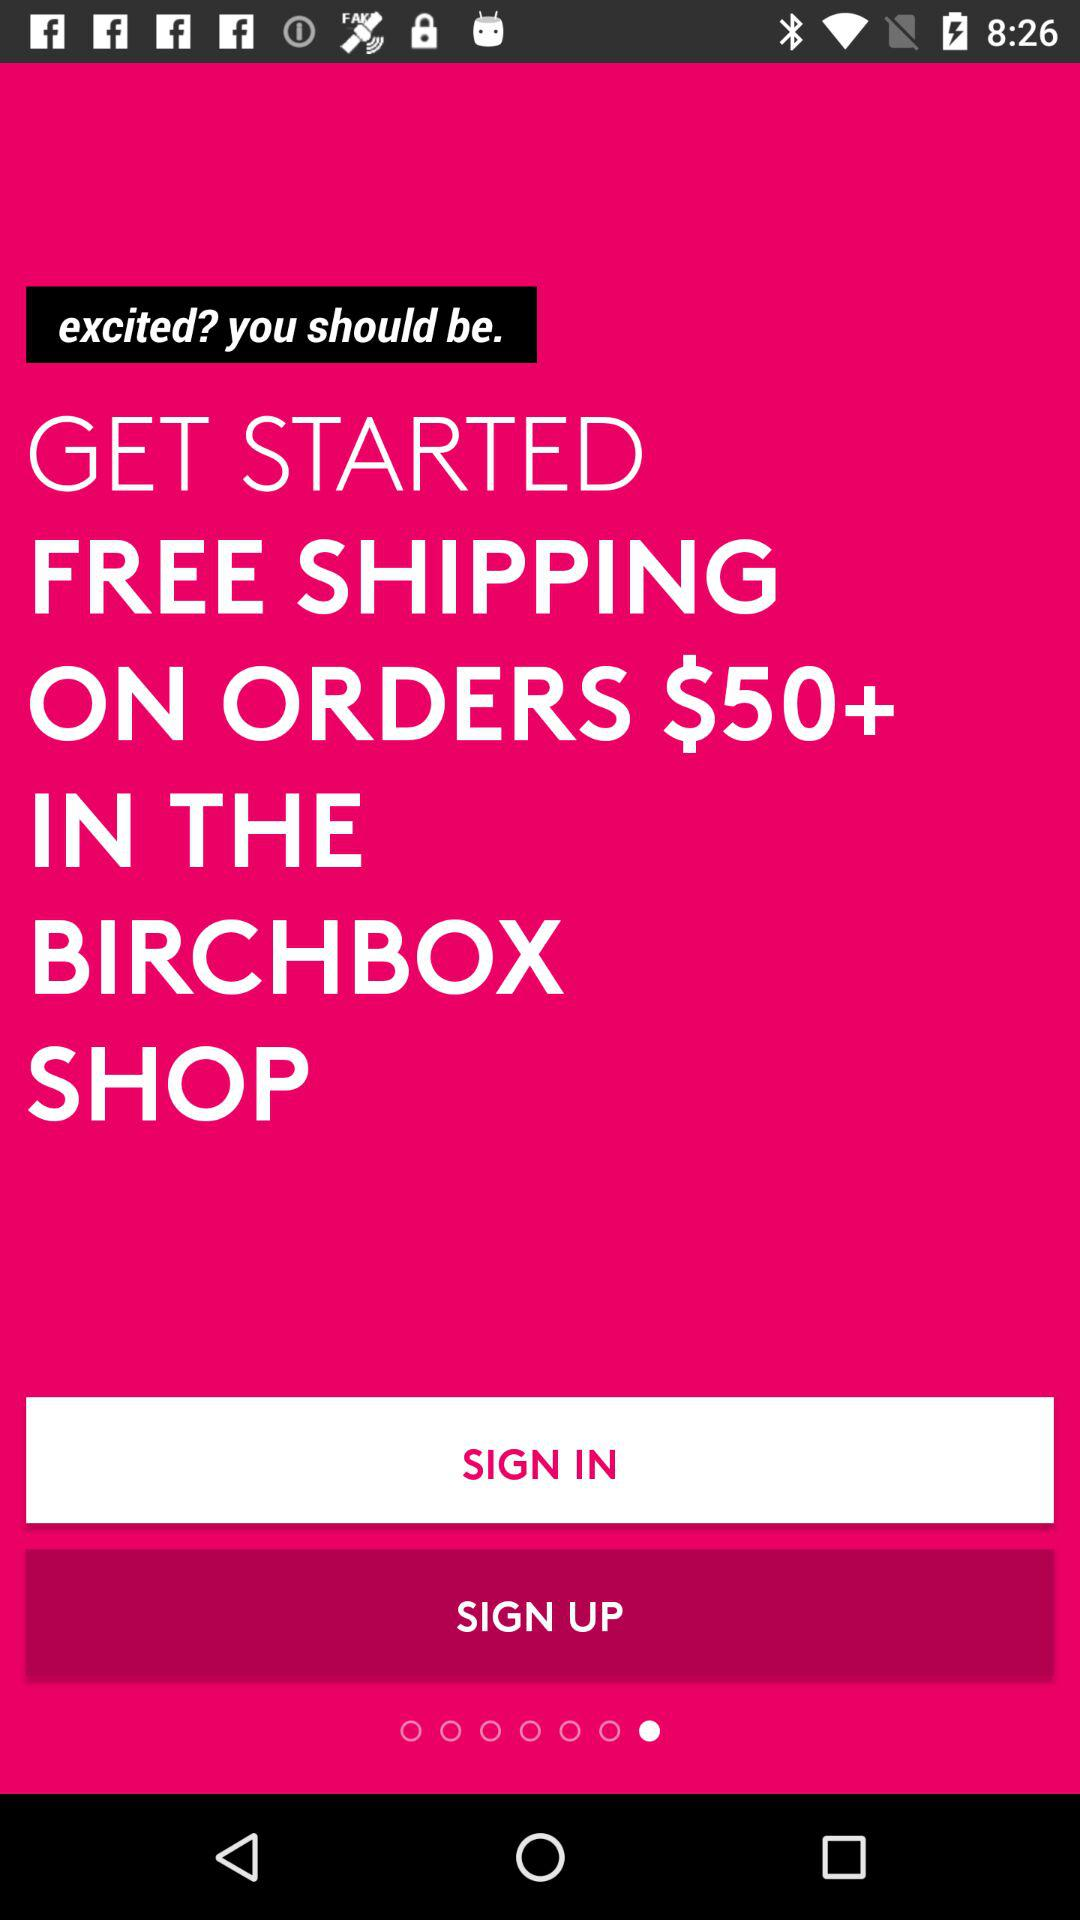Above what order price is free shipping applicable? Free shipping is applicable on order prices above $50. 